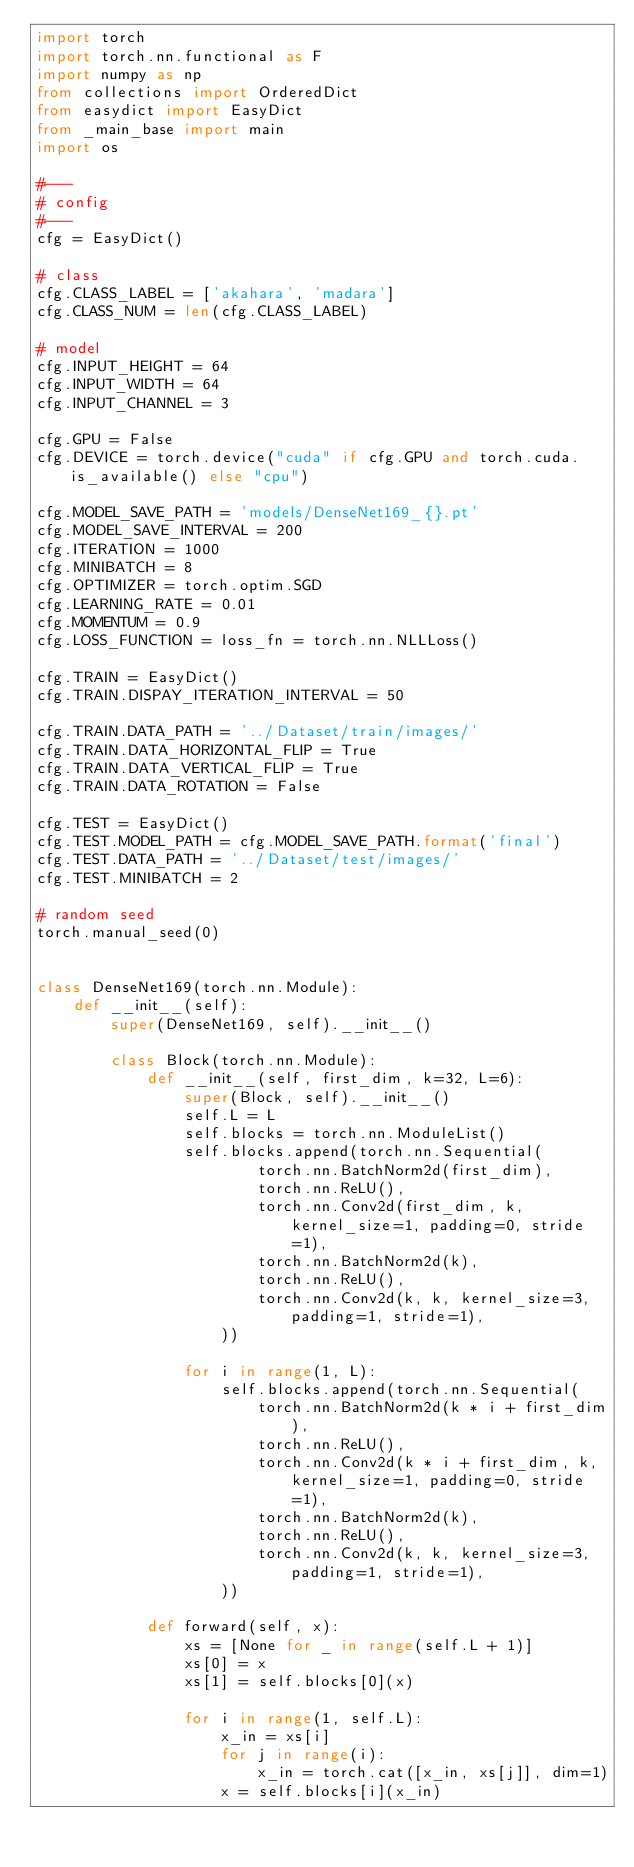<code> <loc_0><loc_0><loc_500><loc_500><_Python_>import torch
import torch.nn.functional as F
import numpy as np
from collections import OrderedDict
from easydict import EasyDict
from _main_base import main
import os

#---
# config
#---
cfg = EasyDict()

# class
cfg.CLASS_LABEL = ['akahara', 'madara']
cfg.CLASS_NUM = len(cfg.CLASS_LABEL)

# model
cfg.INPUT_HEIGHT = 64
cfg.INPUT_WIDTH = 64
cfg.INPUT_CHANNEL = 3

cfg.GPU = False
cfg.DEVICE = torch.device("cuda" if cfg.GPU and torch.cuda.is_available() else "cpu")

cfg.MODEL_SAVE_PATH = 'models/DenseNet169_{}.pt'
cfg.MODEL_SAVE_INTERVAL = 200
cfg.ITERATION = 1000
cfg.MINIBATCH = 8
cfg.OPTIMIZER = torch.optim.SGD
cfg.LEARNING_RATE = 0.01
cfg.MOMENTUM = 0.9
cfg.LOSS_FUNCTION = loss_fn = torch.nn.NLLLoss()

cfg.TRAIN = EasyDict()
cfg.TRAIN.DISPAY_ITERATION_INTERVAL = 50

cfg.TRAIN.DATA_PATH = '../Dataset/train/images/'
cfg.TRAIN.DATA_HORIZONTAL_FLIP = True
cfg.TRAIN.DATA_VERTICAL_FLIP = True
cfg.TRAIN.DATA_ROTATION = False

cfg.TEST = EasyDict()
cfg.TEST.MODEL_PATH = cfg.MODEL_SAVE_PATH.format('final')
cfg.TEST.DATA_PATH = '../Dataset/test/images/'
cfg.TEST.MINIBATCH = 2

# random seed
torch.manual_seed(0)


class DenseNet169(torch.nn.Module):
    def __init__(self):
        super(DenseNet169, self).__init__()

        class Block(torch.nn.Module):
            def __init__(self, first_dim, k=32, L=6):
                super(Block, self).__init__()
                self.L = L
                self.blocks = torch.nn.ModuleList()
                self.blocks.append(torch.nn.Sequential(
                        torch.nn.BatchNorm2d(first_dim),
                        torch.nn.ReLU(),
                        torch.nn.Conv2d(first_dim, k, kernel_size=1, padding=0, stride=1),
                        torch.nn.BatchNorm2d(k),
                        torch.nn.ReLU(),
                        torch.nn.Conv2d(k, k, kernel_size=3, padding=1, stride=1),
                    ))
                
                for i in range(1, L):
                    self.blocks.append(torch.nn.Sequential(
                        torch.nn.BatchNorm2d(k * i + first_dim),
                        torch.nn.ReLU(),
                        torch.nn.Conv2d(k * i + first_dim, k, kernel_size=1, padding=0, stride=1),
                        torch.nn.BatchNorm2d(k),
                        torch.nn.ReLU(),
                        torch.nn.Conv2d(k, k, kernel_size=3, padding=1, stride=1),
                    ))
                
            def forward(self, x):
                xs = [None for _ in range(self.L + 1)]
                xs[0] = x
                xs[1] = self.blocks[0](x)
                
                for i in range(1, self.L):
                    x_in = xs[i]
                    for j in range(i):
                        x_in = torch.cat([x_in, xs[j]], dim=1)
                    x = self.blocks[i](x_in)</code> 